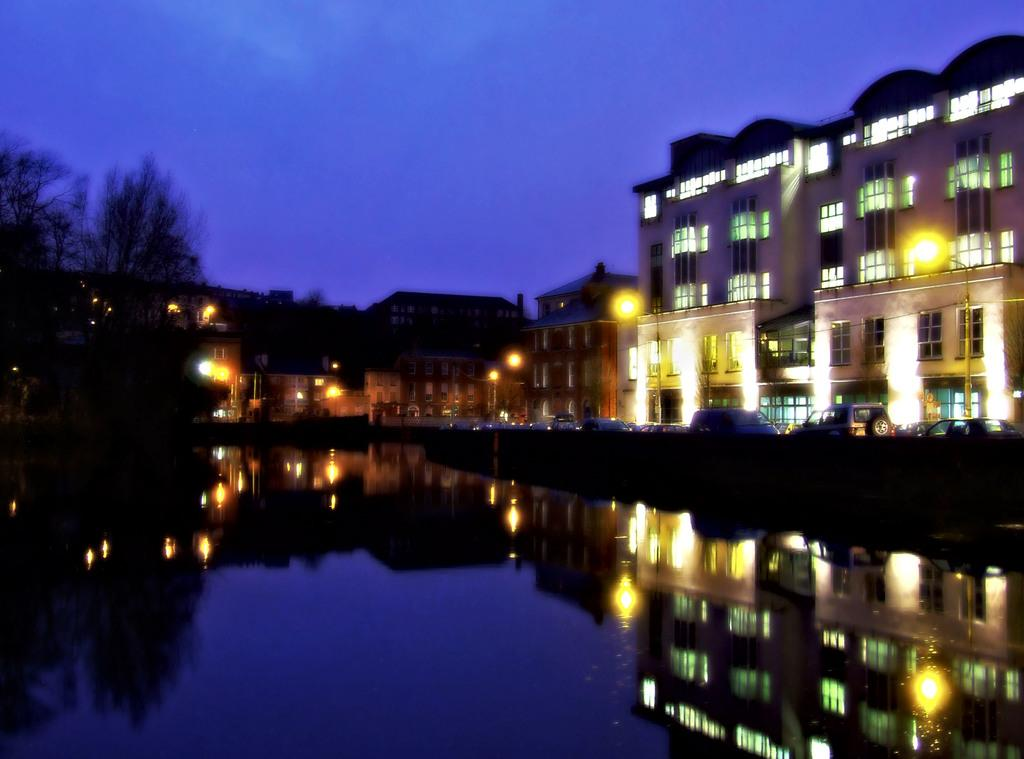What is the primary element visible in the image? There is water in the image. What can be seen in the distance behind the water? There are trees, buildings, and street lights in the background of the image. What is the condition of the sky in the image? The sky is visible in the background of the image. What type of vehicles can be seen on the road in the image? There are cars on the road in the image. What type of harmony can be heard in the image? There is no audible sound in the image, so it is not possible to determine if any harmony can be heard. 